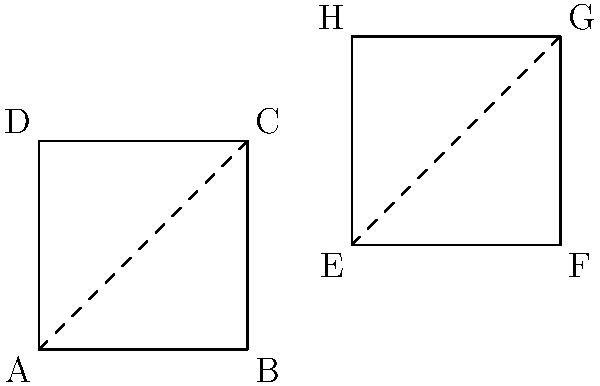While cataloging a set of rare coins for your employer, you notice that the display cases form interesting geometric shapes. Two of the display cases are represented by the quadrilaterals ABCD and EFGH in the diagram. Are these quadrilaterals congruent? If so, explain why. To determine if the quadrilaterals ABCD and EFGH are congruent, we need to check if they have the same shape and size. Let's analyze the properties of both quadrilaterals step by step:

1. Shape: Both quadrilaterals appear to be squares. We can confirm this by checking their properties:
   - All sides seem to be equal in length
   - All angles appear to be right angles (90°)
   - The diagonals (shown as dashed lines) bisect each other

2. Size: To determine if they have the same size, we need to compare their side lengths:
   - ABCD: side length = 2 units (from A to B or D to C)
   - EFGH: side length = 2 units (from E to F or H to G)

3. Congruence criteria: For two squares to be congruent, they only need to have the same side length. We've confirmed that both quadrilaterals are squares with side length 2 units.

4. Congruence transformations: We can map ABCD onto EFGH using a translation of 3 units right and 1 unit up. This rigid transformation preserves the shape and size of the quadrilateral.

5. Definition of congruence: Two figures are congruent if one can be mapped onto the other using a series of rigid transformations (translations, rotations, or reflections).

Given that both quadrilaterals are squares with the same side length, and we can map one onto the other using a translation, we can conclude that quadrilaterals ABCD and EFGH are congruent.
Answer: Yes, congruent 